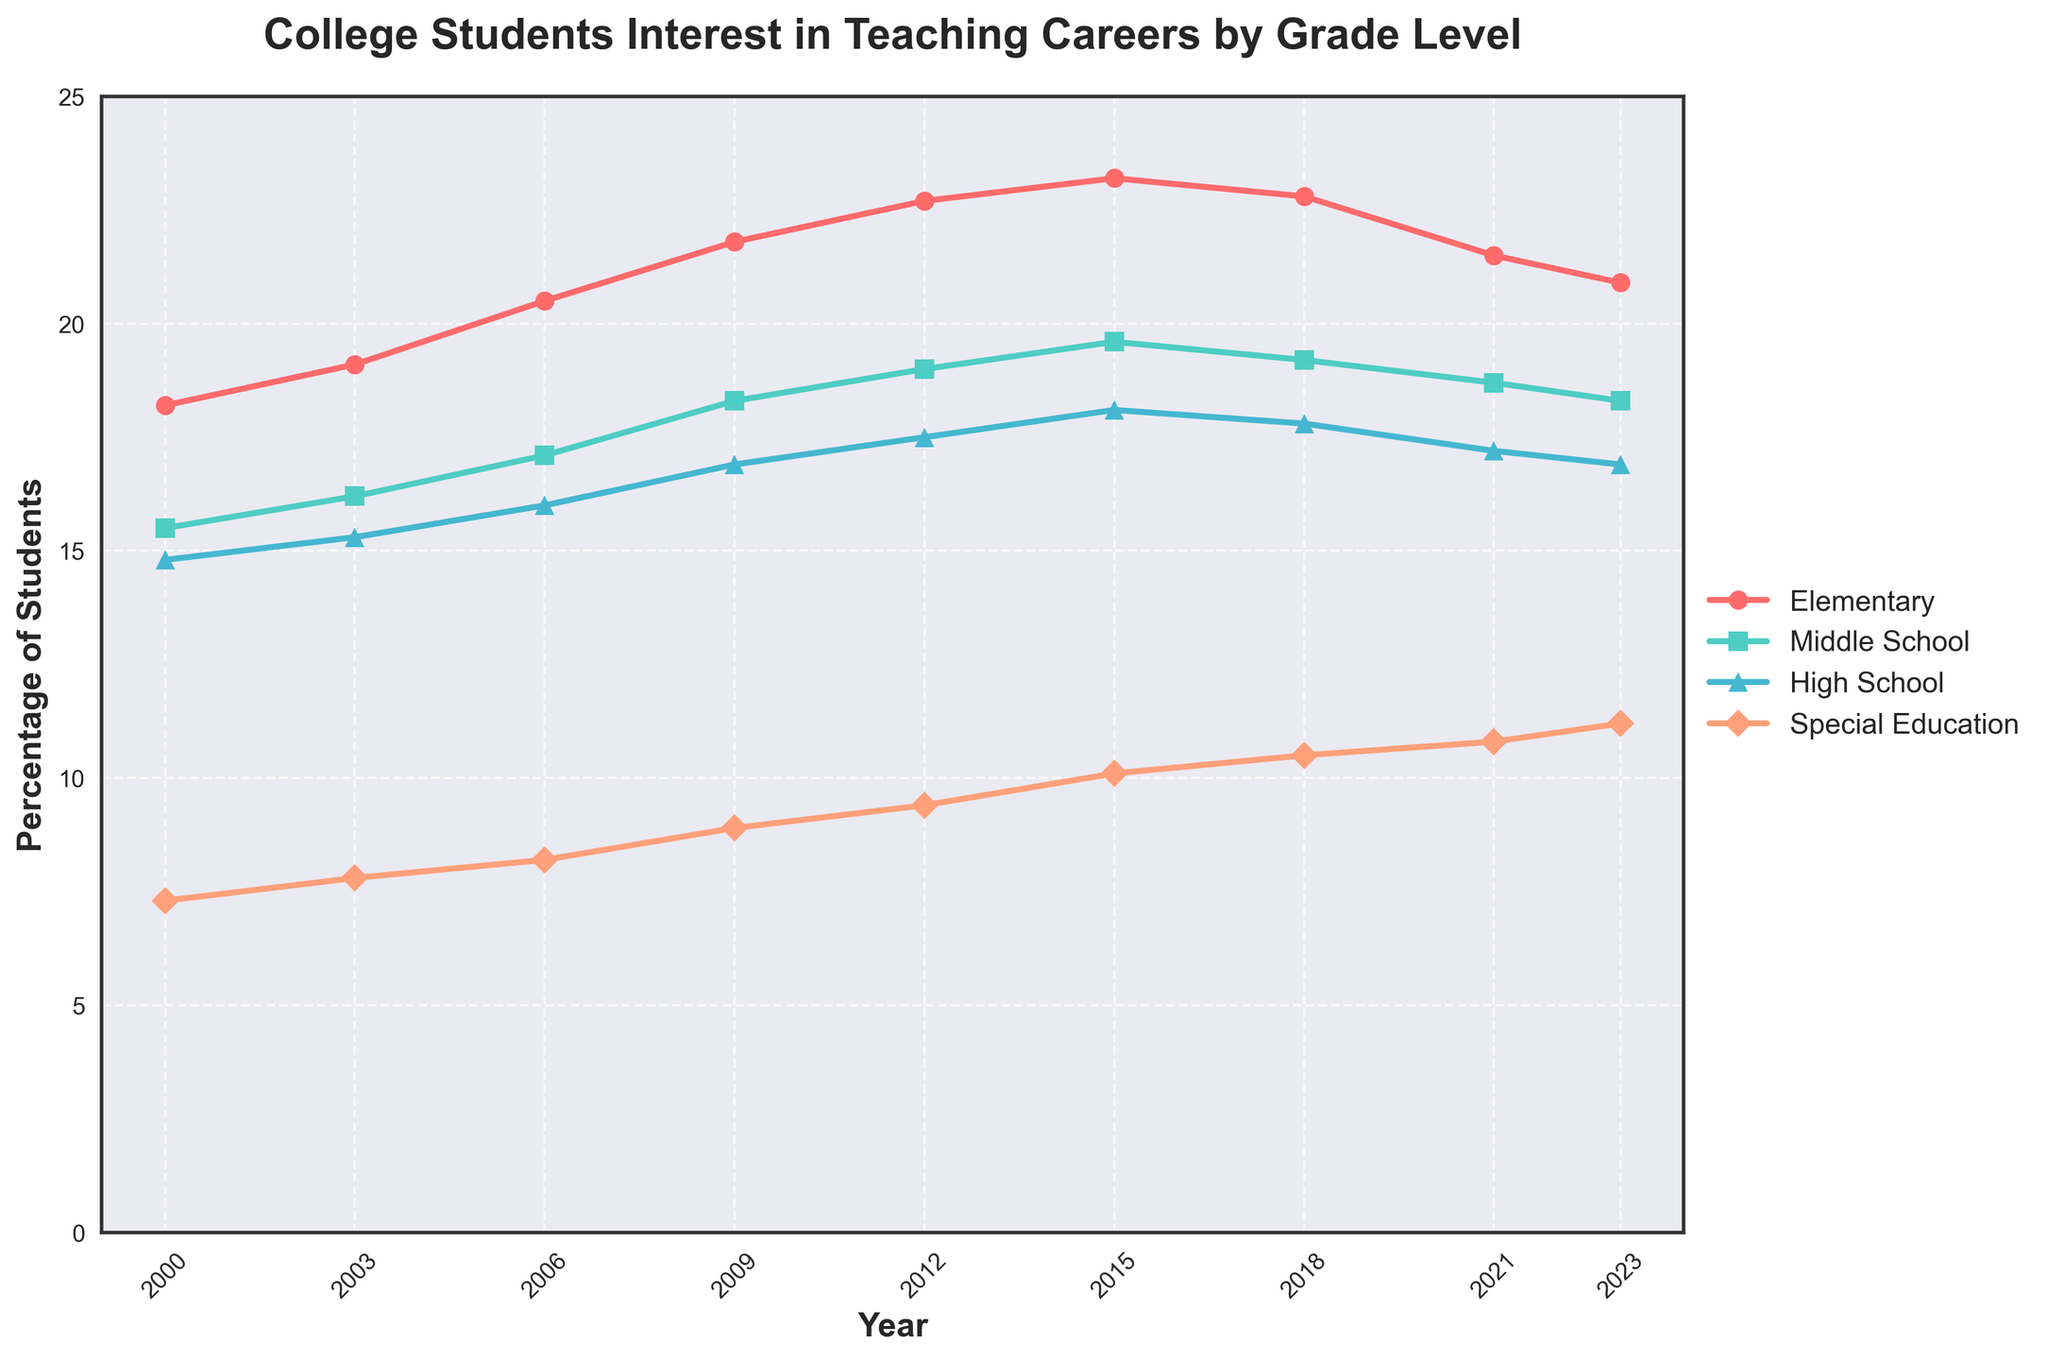What is the percentage of students interested in teaching elementary level in 2023? The plot shows the percentage data for each grade level by year. For 2023, the value for Elementary is about 20.9.
Answer: 20.9 Which grade level saw the highest percentage increase from 2000 to 2023? To determine this, subtract the 2000 value from the 2023 value for each grade level and compare the differences: Elementary (20.9 - 18.2 = 2.7), Middle School (18.3 - 15.5 = 2.8), High School (16.9 - 14.8 = 2.1), Special Education (11.2 - 7.3 = 3.9). Special Education saw the highest increase.
Answer: Special Education Between which two consecutive years did the interest in teaching Middle School increase the most? Look at the plot for Middle School and find the steepest line segment between any two consecutive years. From 2003 to 2006, it increased from 16.2 to 17.1 (0.9 increase). No other consecutive years have a larger increase.
Answer: 2003 to 2006 What is the average percentage of students interested in teaching High School from 2000 to 2023? The percentages for High School are: 14.8, 15.3, 16.0, 16.9, 17.5, 18.1, 17.8, 17.2, and 16.9. Add these and divide by 9: (14.8 + 15.3 + 16.0 + 16.9 + 17.5 + 18.1 + 17.8 + 17.2 + 16.9) / 9. This gives 16.78.
Answer: 16.78 Which grade level experienced a percentage decline between 2015 and 2021? Check the data points for each grade level between 2015 and 2021: Elementary (23.2 to 21.5, decline), Middle School (19.6 to 18.7, decline), High School (18.1 to 17.2, decline), Special Education (10.1 to 10.8, increase).
Answer: Elementary, Middle School, High School What is the difference in percentage of students interested in teaching Special Education between 2009 and 2023? Subtract the percentage of Special Education in 2009 from that in 2023: 11.2 - 8.9 = 2.3.
Answer: 2.3 Which grade level had the lowest percentage in 2000 and how much was it? Identify the lowest value for the year 2000 among the four grade levels: Elementary (18.2), Middle School (15.5), High School (14.8), Special Education (7.3). Special Education is the lowest.
Answer: Special Education, 7.3 How did the percentage of students interested in teaching Elementary level change from 2018 to 2021? Look at the values for Elementary level in 2018 and 2021: 22.8 in 2018 and 21.5 in 2021. The change is 21.5 - 22.8 = -1.3 (a decline).
Answer: Declined by 1.3 